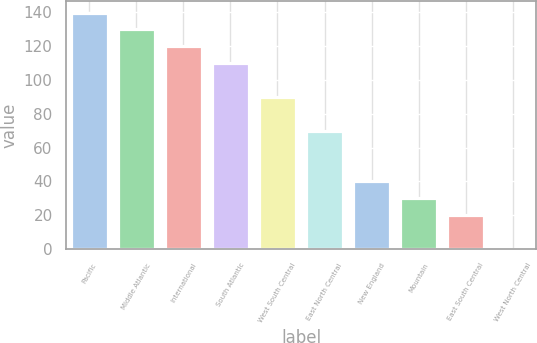Convert chart to OTSL. <chart><loc_0><loc_0><loc_500><loc_500><bar_chart><fcel>Pacific<fcel>Middle Atlantic<fcel>International<fcel>South Atlantic<fcel>West South Central<fcel>East North Central<fcel>New England<fcel>Mountain<fcel>East South Central<fcel>West North Central<nl><fcel>139.88<fcel>129.91<fcel>119.94<fcel>109.97<fcel>90.03<fcel>70.09<fcel>40.18<fcel>30.21<fcel>20.24<fcel>0.3<nl></chart> 